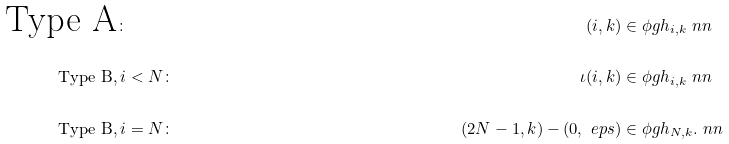Convert formula to latex. <formula><loc_0><loc_0><loc_500><loc_500>\text {Type A} & \colon & ( i , k ) & \in \phi g h _ { i , k } \ n n \\ \text {Type B} , & \, i < N \colon & \iota ( i , k ) & \in \phi g h _ { i , k } \ n n \\ \text {Type B} , & \, i = N \colon & ( 2 N - 1 , k ) - ( 0 , \ e p s ) & \in \phi g h _ { N , k } . \ n n</formula> 